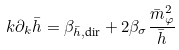<formula> <loc_0><loc_0><loc_500><loc_500>k \partial _ { k } \bar { h } = \beta _ { \bar { h } , \text {dir} } + 2 \beta _ { \sigma } \frac { \bar { m } _ { \varphi } ^ { 2 } } { \bar { h } }</formula> 